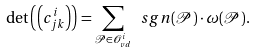Convert formula to latex. <formula><loc_0><loc_0><loc_500><loc_500>\det \left ( \left ( c ^ { i } _ { j k } \right ) \right ) = \sum _ { \mathcal { P } \in \mathcal { O } ^ { i } _ { v d } } \ s g n ( \mathcal { P } ) \cdot \omega ( \mathcal { P } ) .</formula> 